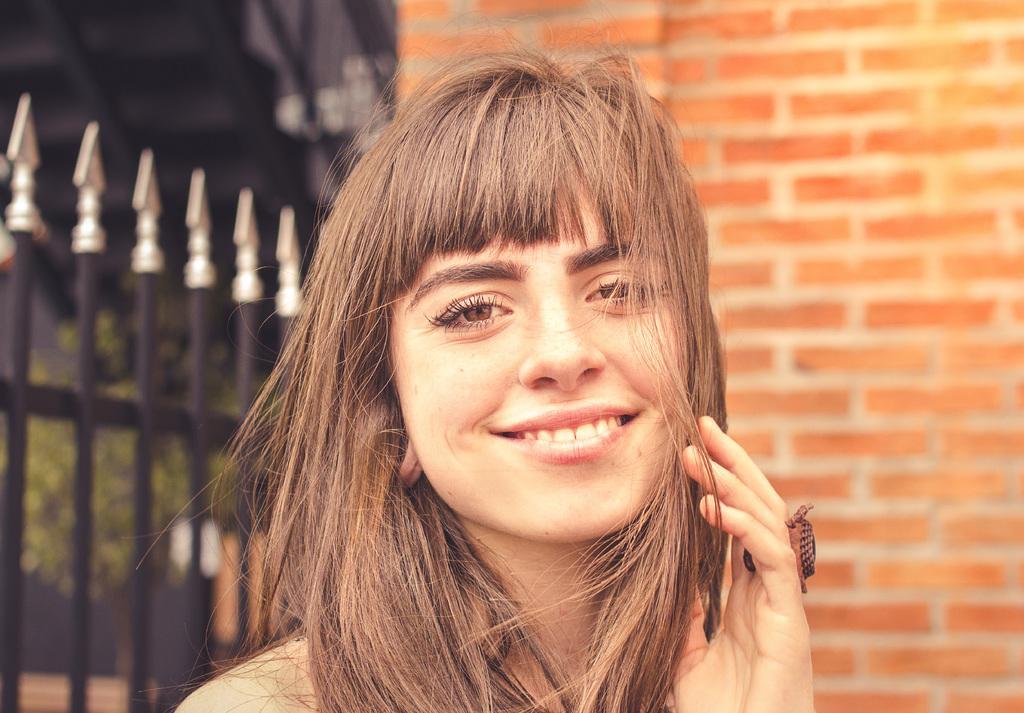In one or two sentences, can you explain what this image depicts? In this picture we can see a woman, she is smiling, behind to her we can see a wall, fence and few plants. 